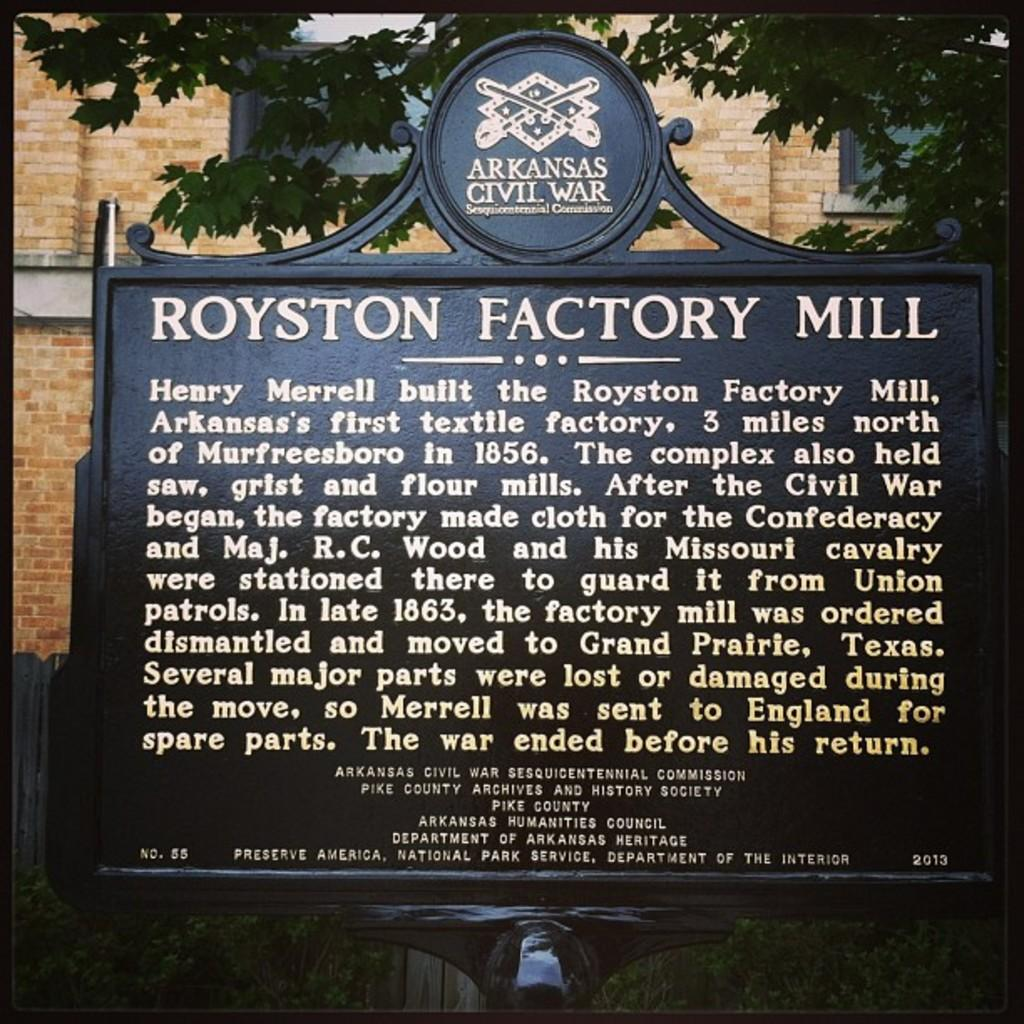What is on the board that is visible in the image? There is text on the board in the image. What can be seen in the background of the image? There is a building and a tree in the background of the image. What is located at the back of the board? There is a fencing at the back of the board. What type of steel is used to make the drink in the image? There is no drink present in the image, and therefore no steel can be associated with it. 